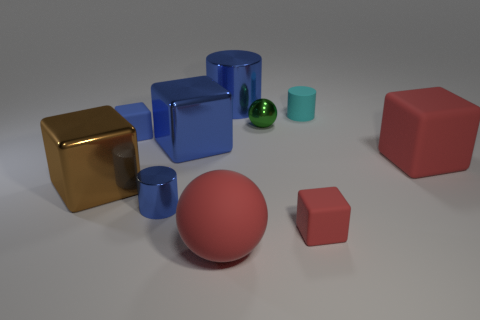Subtract 1 cubes. How many cubes are left? 4 Subtract all big red matte blocks. How many blocks are left? 4 Subtract all gray blocks. Subtract all cyan balls. How many blocks are left? 5 Subtract all balls. How many objects are left? 8 Add 6 brown cubes. How many brown cubes are left? 7 Add 6 tiny blocks. How many tiny blocks exist? 8 Subtract 0 brown cylinders. How many objects are left? 10 Subtract all big brown shiny cylinders. Subtract all tiny blocks. How many objects are left? 8 